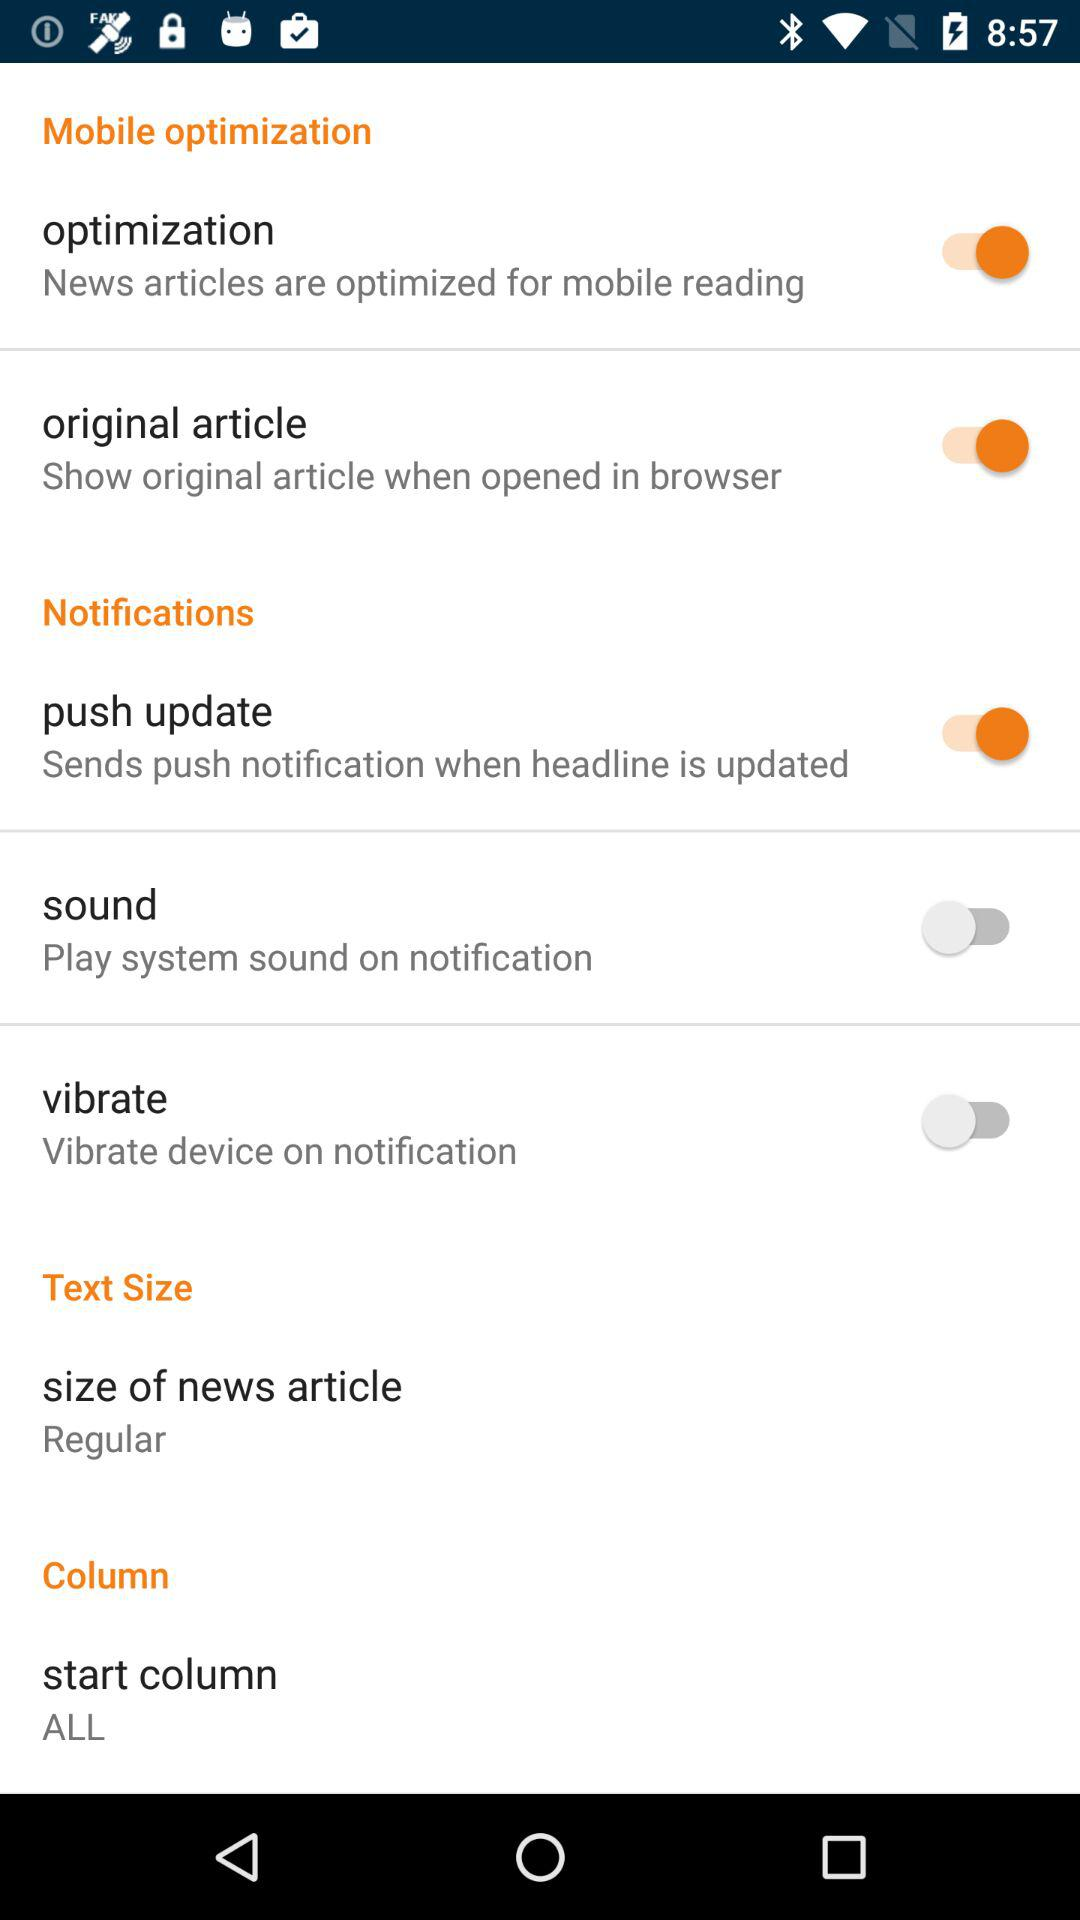What is the size of the news article? The size is regular. 